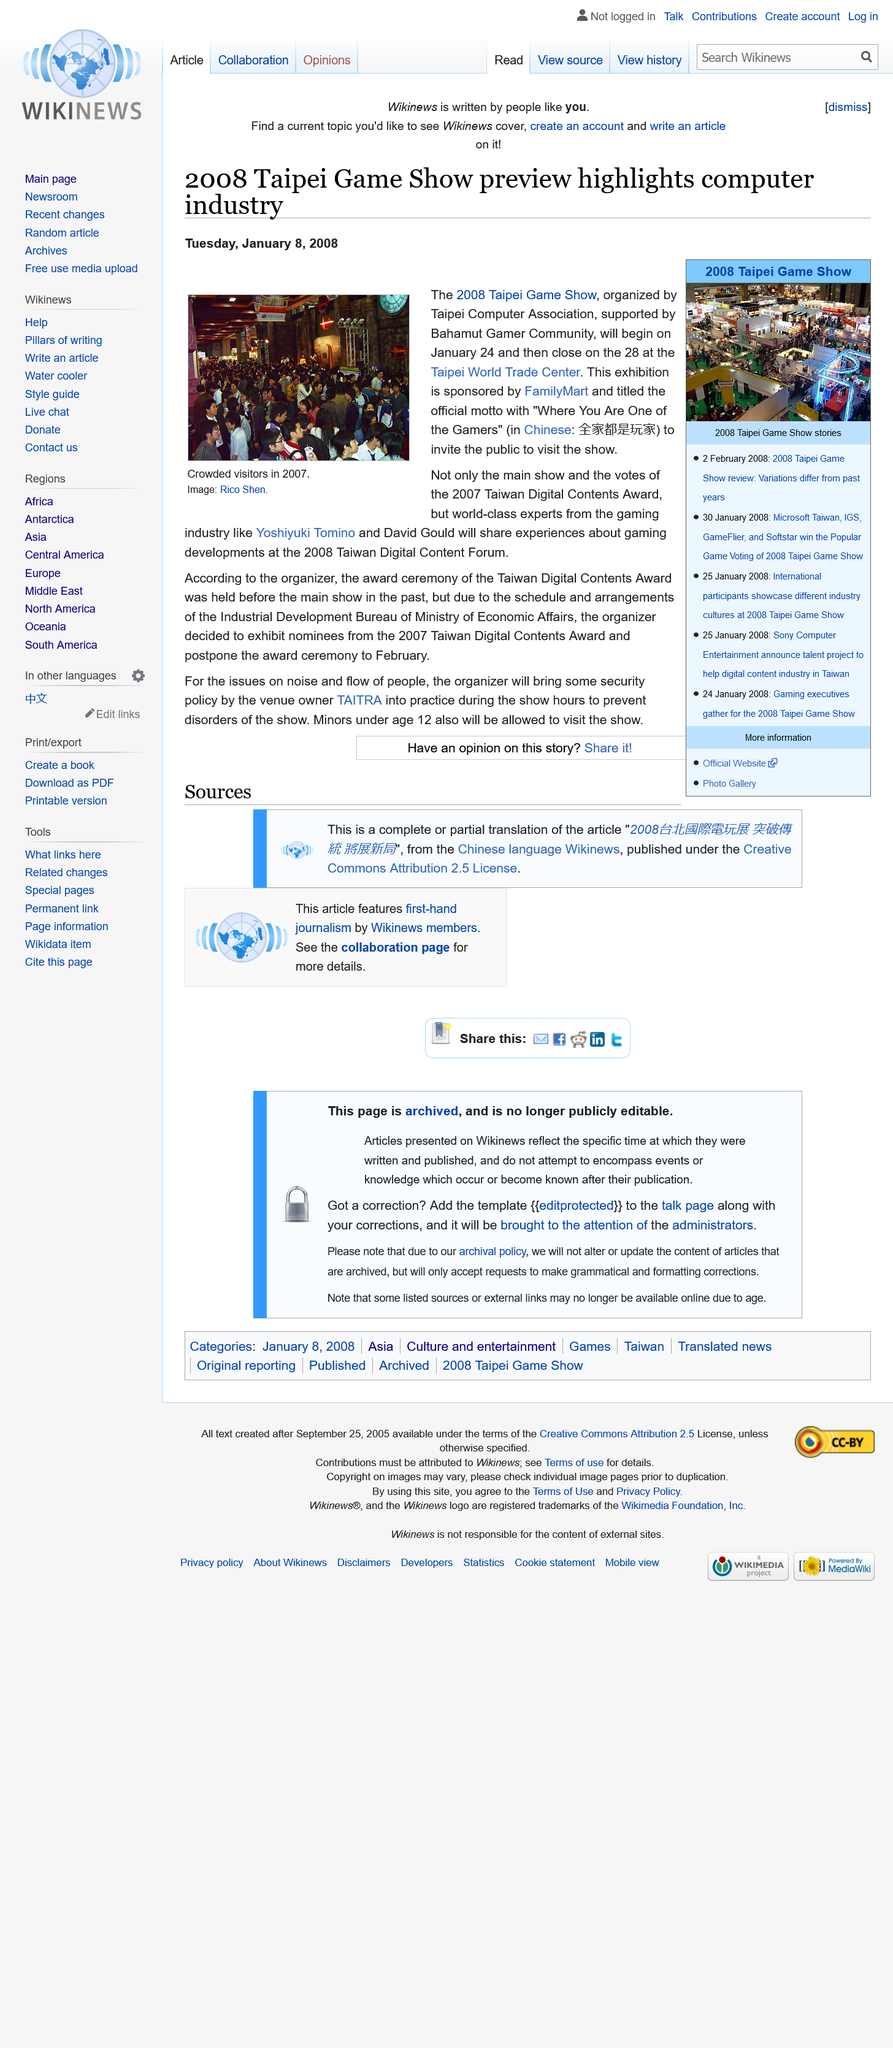Point out several critical features in this image. The 2008 Taipei Game Show was held at the Taipei World Trade Center. The Taipei Game Show began on January 24, 2008. Two world-renowned experts from the gaming industry, Yoshiyuki Tomino and David Gould, shared their knowledge and experiences about gaming developments at the 2008 Taiwan Digital Content Forum. 